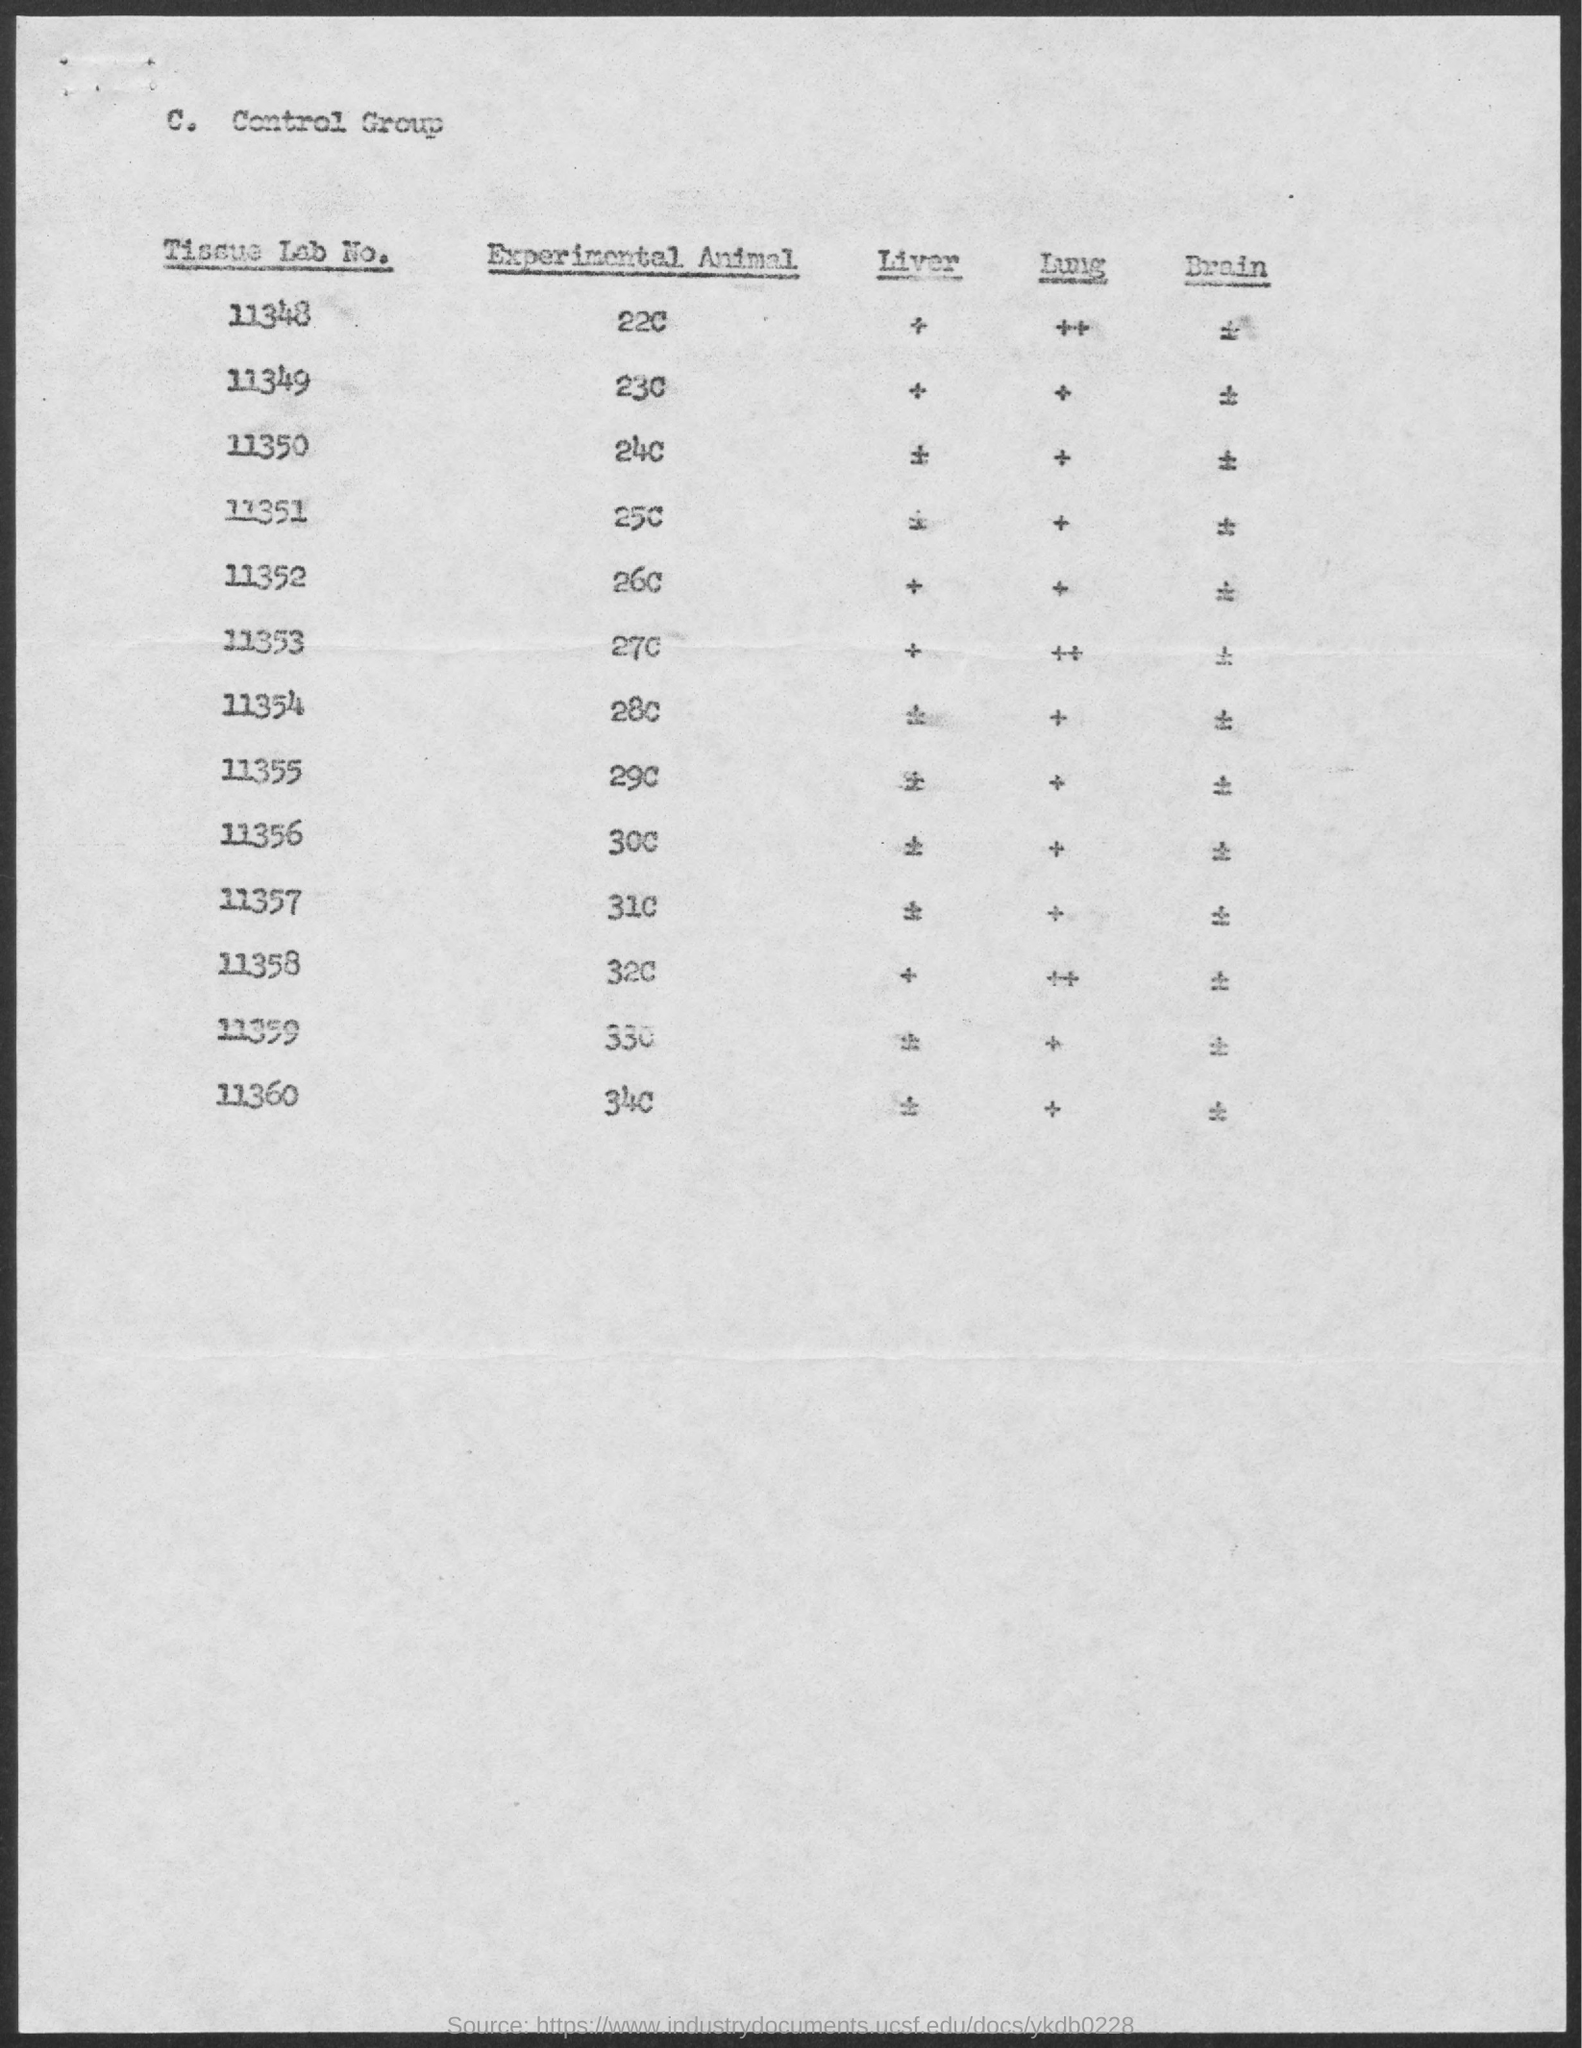Highlight a few significant elements in this photo. The value of the experimental animal for tissue lab number 11353 is 27c.. The value of the experimental animal for tissue lab number 11358 is 32c. The value of experimental animal for tissue lab number 11348 is 22c. The tissue lab number for the value of 25c in an experimental animal is 11351. Experimental animal number 11360 has a value of 34c for the tissue lab. 